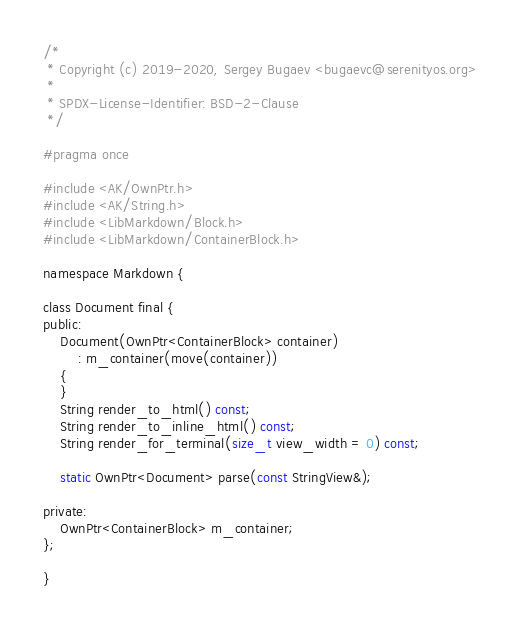Convert code to text. <code><loc_0><loc_0><loc_500><loc_500><_C_>/*
 * Copyright (c) 2019-2020, Sergey Bugaev <bugaevc@serenityos.org>
 *
 * SPDX-License-Identifier: BSD-2-Clause
 */

#pragma once

#include <AK/OwnPtr.h>
#include <AK/String.h>
#include <LibMarkdown/Block.h>
#include <LibMarkdown/ContainerBlock.h>

namespace Markdown {

class Document final {
public:
    Document(OwnPtr<ContainerBlock> container)
        : m_container(move(container))
    {
    }
    String render_to_html() const;
    String render_to_inline_html() const;
    String render_for_terminal(size_t view_width = 0) const;

    static OwnPtr<Document> parse(const StringView&);

private:
    OwnPtr<ContainerBlock> m_container;
};

}
</code> 